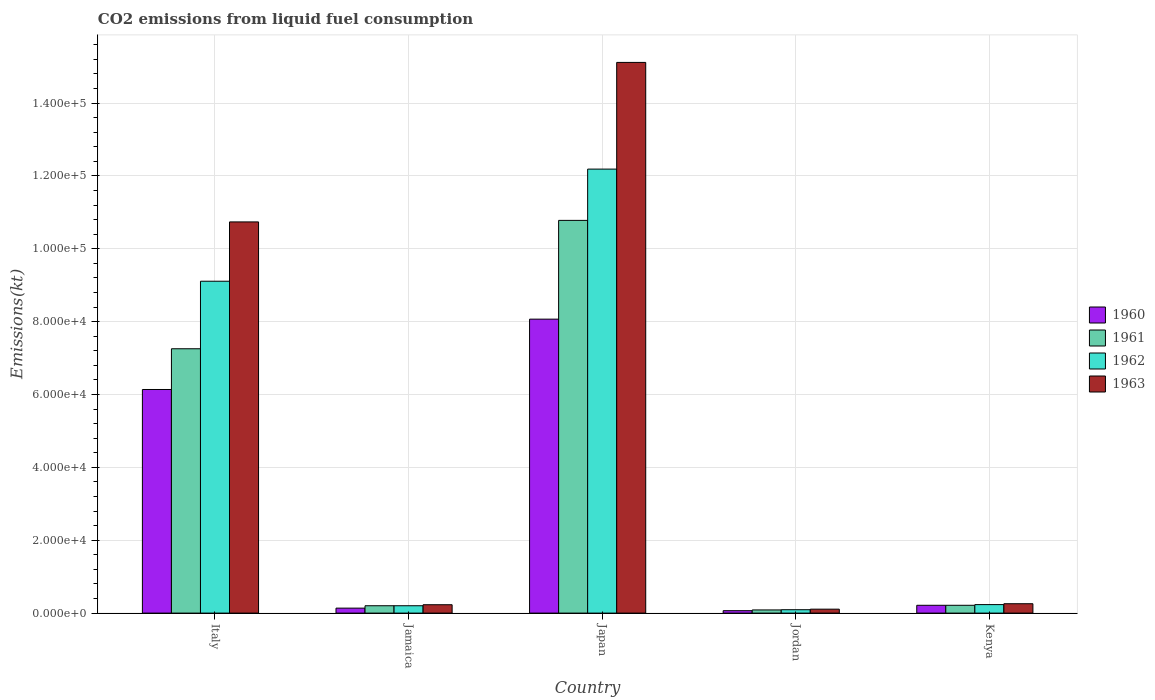How many groups of bars are there?
Make the answer very short. 5. Are the number of bars per tick equal to the number of legend labels?
Offer a very short reply. Yes. How many bars are there on the 4th tick from the right?
Offer a very short reply. 4. In how many cases, is the number of bars for a given country not equal to the number of legend labels?
Give a very brief answer. 0. What is the amount of CO2 emitted in 1963 in Jordan?
Your response must be concise. 1078.1. Across all countries, what is the maximum amount of CO2 emitted in 1960?
Your answer should be very brief. 8.07e+04. Across all countries, what is the minimum amount of CO2 emitted in 1960?
Give a very brief answer. 663.73. In which country was the amount of CO2 emitted in 1962 minimum?
Your answer should be compact. Jordan. What is the total amount of CO2 emitted in 1962 in the graph?
Keep it short and to the point. 2.18e+05. What is the difference between the amount of CO2 emitted in 1961 in Italy and that in Jamaica?
Provide a short and direct response. 7.05e+04. What is the difference between the amount of CO2 emitted in 1962 in Kenya and the amount of CO2 emitted in 1961 in Japan?
Make the answer very short. -1.05e+05. What is the average amount of CO2 emitted in 1961 per country?
Your answer should be very brief. 3.71e+04. What is the difference between the amount of CO2 emitted of/in 1963 and amount of CO2 emitted of/in 1961 in Kenya?
Provide a short and direct response. 429.04. In how many countries, is the amount of CO2 emitted in 1962 greater than 116000 kt?
Your response must be concise. 1. What is the ratio of the amount of CO2 emitted in 1961 in Japan to that in Kenya?
Your response must be concise. 50.33. What is the difference between the highest and the second highest amount of CO2 emitted in 1963?
Provide a succinct answer. 1.49e+05. What is the difference between the highest and the lowest amount of CO2 emitted in 1962?
Offer a terse response. 1.21e+05. In how many countries, is the amount of CO2 emitted in 1961 greater than the average amount of CO2 emitted in 1961 taken over all countries?
Your response must be concise. 2. Is the sum of the amount of CO2 emitted in 1962 in Jordan and Kenya greater than the maximum amount of CO2 emitted in 1963 across all countries?
Give a very brief answer. No. Is it the case that in every country, the sum of the amount of CO2 emitted in 1962 and amount of CO2 emitted in 1961 is greater than the sum of amount of CO2 emitted in 1963 and amount of CO2 emitted in 1960?
Make the answer very short. No. How many bars are there?
Keep it short and to the point. 20. Are all the bars in the graph horizontal?
Your answer should be very brief. No. How many countries are there in the graph?
Provide a short and direct response. 5. What is the difference between two consecutive major ticks on the Y-axis?
Provide a succinct answer. 2.00e+04. Does the graph contain grids?
Provide a short and direct response. Yes. How many legend labels are there?
Provide a succinct answer. 4. How are the legend labels stacked?
Provide a succinct answer. Vertical. What is the title of the graph?
Provide a succinct answer. CO2 emissions from liquid fuel consumption. What is the label or title of the X-axis?
Provide a short and direct response. Country. What is the label or title of the Y-axis?
Your response must be concise. Emissions(kt). What is the Emissions(kt) of 1960 in Italy?
Ensure brevity in your answer.  6.14e+04. What is the Emissions(kt) of 1961 in Italy?
Provide a short and direct response. 7.26e+04. What is the Emissions(kt) of 1962 in Italy?
Make the answer very short. 9.11e+04. What is the Emissions(kt) in 1963 in Italy?
Your answer should be very brief. 1.07e+05. What is the Emissions(kt) in 1960 in Jamaica?
Your answer should be compact. 1364.12. What is the Emissions(kt) in 1961 in Jamaica?
Your answer should be very brief. 2020.52. What is the Emissions(kt) in 1962 in Jamaica?
Your answer should be compact. 2016.85. What is the Emissions(kt) of 1963 in Jamaica?
Your response must be concise. 2295.54. What is the Emissions(kt) of 1960 in Japan?
Keep it short and to the point. 8.07e+04. What is the Emissions(kt) in 1961 in Japan?
Provide a succinct answer. 1.08e+05. What is the Emissions(kt) of 1962 in Japan?
Your answer should be compact. 1.22e+05. What is the Emissions(kt) in 1963 in Japan?
Offer a terse response. 1.51e+05. What is the Emissions(kt) in 1960 in Jordan?
Provide a short and direct response. 663.73. What is the Emissions(kt) of 1961 in Jordan?
Offer a terse response. 869.08. What is the Emissions(kt) of 1962 in Jordan?
Your answer should be very brief. 931.42. What is the Emissions(kt) in 1963 in Jordan?
Your answer should be compact. 1078.1. What is the Emissions(kt) of 1960 in Kenya?
Your answer should be very brief. 2141.53. What is the Emissions(kt) in 1961 in Kenya?
Your response must be concise. 2141.53. What is the Emissions(kt) in 1962 in Kenya?
Your answer should be very brief. 2332.21. What is the Emissions(kt) in 1963 in Kenya?
Offer a terse response. 2570.57. Across all countries, what is the maximum Emissions(kt) in 1960?
Offer a terse response. 8.07e+04. Across all countries, what is the maximum Emissions(kt) in 1961?
Keep it short and to the point. 1.08e+05. Across all countries, what is the maximum Emissions(kt) in 1962?
Give a very brief answer. 1.22e+05. Across all countries, what is the maximum Emissions(kt) of 1963?
Keep it short and to the point. 1.51e+05. Across all countries, what is the minimum Emissions(kt) in 1960?
Provide a short and direct response. 663.73. Across all countries, what is the minimum Emissions(kt) in 1961?
Give a very brief answer. 869.08. Across all countries, what is the minimum Emissions(kt) of 1962?
Your response must be concise. 931.42. Across all countries, what is the minimum Emissions(kt) in 1963?
Your answer should be compact. 1078.1. What is the total Emissions(kt) in 1960 in the graph?
Make the answer very short. 1.46e+05. What is the total Emissions(kt) of 1961 in the graph?
Offer a terse response. 1.85e+05. What is the total Emissions(kt) in 1962 in the graph?
Your answer should be compact. 2.18e+05. What is the total Emissions(kt) of 1963 in the graph?
Provide a short and direct response. 2.64e+05. What is the difference between the Emissions(kt) in 1960 in Italy and that in Jamaica?
Make the answer very short. 6.00e+04. What is the difference between the Emissions(kt) in 1961 in Italy and that in Jamaica?
Your answer should be compact. 7.05e+04. What is the difference between the Emissions(kt) of 1962 in Italy and that in Jamaica?
Your answer should be very brief. 8.91e+04. What is the difference between the Emissions(kt) of 1963 in Italy and that in Jamaica?
Offer a very short reply. 1.05e+05. What is the difference between the Emissions(kt) in 1960 in Italy and that in Japan?
Provide a succinct answer. -1.93e+04. What is the difference between the Emissions(kt) in 1961 in Italy and that in Japan?
Make the answer very short. -3.52e+04. What is the difference between the Emissions(kt) in 1962 in Italy and that in Japan?
Provide a succinct answer. -3.08e+04. What is the difference between the Emissions(kt) in 1963 in Italy and that in Japan?
Make the answer very short. -4.38e+04. What is the difference between the Emissions(kt) of 1960 in Italy and that in Jordan?
Make the answer very short. 6.07e+04. What is the difference between the Emissions(kt) of 1961 in Italy and that in Jordan?
Give a very brief answer. 7.17e+04. What is the difference between the Emissions(kt) of 1962 in Italy and that in Jordan?
Your answer should be very brief. 9.02e+04. What is the difference between the Emissions(kt) in 1963 in Italy and that in Jordan?
Offer a very short reply. 1.06e+05. What is the difference between the Emissions(kt) in 1960 in Italy and that in Kenya?
Your answer should be very brief. 5.92e+04. What is the difference between the Emissions(kt) in 1961 in Italy and that in Kenya?
Provide a succinct answer. 7.04e+04. What is the difference between the Emissions(kt) of 1962 in Italy and that in Kenya?
Ensure brevity in your answer.  8.88e+04. What is the difference between the Emissions(kt) in 1963 in Italy and that in Kenya?
Your response must be concise. 1.05e+05. What is the difference between the Emissions(kt) in 1960 in Jamaica and that in Japan?
Your response must be concise. -7.93e+04. What is the difference between the Emissions(kt) of 1961 in Jamaica and that in Japan?
Keep it short and to the point. -1.06e+05. What is the difference between the Emissions(kt) in 1962 in Jamaica and that in Japan?
Make the answer very short. -1.20e+05. What is the difference between the Emissions(kt) in 1963 in Jamaica and that in Japan?
Provide a short and direct response. -1.49e+05. What is the difference between the Emissions(kt) of 1960 in Jamaica and that in Jordan?
Your answer should be compact. 700.4. What is the difference between the Emissions(kt) in 1961 in Jamaica and that in Jordan?
Provide a short and direct response. 1151.44. What is the difference between the Emissions(kt) in 1962 in Jamaica and that in Jordan?
Your answer should be compact. 1085.43. What is the difference between the Emissions(kt) of 1963 in Jamaica and that in Jordan?
Provide a succinct answer. 1217.44. What is the difference between the Emissions(kt) in 1960 in Jamaica and that in Kenya?
Make the answer very short. -777.4. What is the difference between the Emissions(kt) of 1961 in Jamaica and that in Kenya?
Offer a terse response. -121.01. What is the difference between the Emissions(kt) in 1962 in Jamaica and that in Kenya?
Provide a succinct answer. -315.36. What is the difference between the Emissions(kt) in 1963 in Jamaica and that in Kenya?
Offer a terse response. -275.02. What is the difference between the Emissions(kt) of 1960 in Japan and that in Jordan?
Ensure brevity in your answer.  8.00e+04. What is the difference between the Emissions(kt) of 1961 in Japan and that in Jordan?
Keep it short and to the point. 1.07e+05. What is the difference between the Emissions(kt) of 1962 in Japan and that in Jordan?
Offer a very short reply. 1.21e+05. What is the difference between the Emissions(kt) in 1963 in Japan and that in Jordan?
Make the answer very short. 1.50e+05. What is the difference between the Emissions(kt) in 1960 in Japan and that in Kenya?
Provide a succinct answer. 7.85e+04. What is the difference between the Emissions(kt) of 1961 in Japan and that in Kenya?
Keep it short and to the point. 1.06e+05. What is the difference between the Emissions(kt) of 1962 in Japan and that in Kenya?
Offer a very short reply. 1.20e+05. What is the difference between the Emissions(kt) in 1963 in Japan and that in Kenya?
Offer a terse response. 1.49e+05. What is the difference between the Emissions(kt) of 1960 in Jordan and that in Kenya?
Make the answer very short. -1477.8. What is the difference between the Emissions(kt) of 1961 in Jordan and that in Kenya?
Make the answer very short. -1272.45. What is the difference between the Emissions(kt) in 1962 in Jordan and that in Kenya?
Your response must be concise. -1400.79. What is the difference between the Emissions(kt) of 1963 in Jordan and that in Kenya?
Keep it short and to the point. -1492.47. What is the difference between the Emissions(kt) in 1960 in Italy and the Emissions(kt) in 1961 in Jamaica?
Keep it short and to the point. 5.94e+04. What is the difference between the Emissions(kt) in 1960 in Italy and the Emissions(kt) in 1962 in Jamaica?
Offer a terse response. 5.94e+04. What is the difference between the Emissions(kt) in 1960 in Italy and the Emissions(kt) in 1963 in Jamaica?
Offer a terse response. 5.91e+04. What is the difference between the Emissions(kt) of 1961 in Italy and the Emissions(kt) of 1962 in Jamaica?
Offer a very short reply. 7.05e+04. What is the difference between the Emissions(kt) in 1961 in Italy and the Emissions(kt) in 1963 in Jamaica?
Offer a terse response. 7.03e+04. What is the difference between the Emissions(kt) of 1962 in Italy and the Emissions(kt) of 1963 in Jamaica?
Make the answer very short. 8.88e+04. What is the difference between the Emissions(kt) of 1960 in Italy and the Emissions(kt) of 1961 in Japan?
Offer a terse response. -4.64e+04. What is the difference between the Emissions(kt) in 1960 in Italy and the Emissions(kt) in 1962 in Japan?
Offer a very short reply. -6.05e+04. What is the difference between the Emissions(kt) of 1960 in Italy and the Emissions(kt) of 1963 in Japan?
Make the answer very short. -8.98e+04. What is the difference between the Emissions(kt) of 1961 in Italy and the Emissions(kt) of 1962 in Japan?
Offer a terse response. -4.93e+04. What is the difference between the Emissions(kt) of 1961 in Italy and the Emissions(kt) of 1963 in Japan?
Provide a short and direct response. -7.86e+04. What is the difference between the Emissions(kt) of 1962 in Italy and the Emissions(kt) of 1963 in Japan?
Ensure brevity in your answer.  -6.01e+04. What is the difference between the Emissions(kt) in 1960 in Italy and the Emissions(kt) in 1961 in Jordan?
Your response must be concise. 6.05e+04. What is the difference between the Emissions(kt) of 1960 in Italy and the Emissions(kt) of 1962 in Jordan?
Ensure brevity in your answer.  6.04e+04. What is the difference between the Emissions(kt) in 1960 in Italy and the Emissions(kt) in 1963 in Jordan?
Keep it short and to the point. 6.03e+04. What is the difference between the Emissions(kt) of 1961 in Italy and the Emissions(kt) of 1962 in Jordan?
Offer a terse response. 7.16e+04. What is the difference between the Emissions(kt) of 1961 in Italy and the Emissions(kt) of 1963 in Jordan?
Keep it short and to the point. 7.15e+04. What is the difference between the Emissions(kt) in 1962 in Italy and the Emissions(kt) in 1963 in Jordan?
Offer a terse response. 9.00e+04. What is the difference between the Emissions(kt) in 1960 in Italy and the Emissions(kt) in 1961 in Kenya?
Provide a succinct answer. 5.92e+04. What is the difference between the Emissions(kt) of 1960 in Italy and the Emissions(kt) of 1962 in Kenya?
Keep it short and to the point. 5.90e+04. What is the difference between the Emissions(kt) in 1960 in Italy and the Emissions(kt) in 1963 in Kenya?
Ensure brevity in your answer.  5.88e+04. What is the difference between the Emissions(kt) of 1961 in Italy and the Emissions(kt) of 1962 in Kenya?
Provide a succinct answer. 7.02e+04. What is the difference between the Emissions(kt) of 1961 in Italy and the Emissions(kt) of 1963 in Kenya?
Give a very brief answer. 7.00e+04. What is the difference between the Emissions(kt) of 1962 in Italy and the Emissions(kt) of 1963 in Kenya?
Give a very brief answer. 8.85e+04. What is the difference between the Emissions(kt) of 1960 in Jamaica and the Emissions(kt) of 1961 in Japan?
Your response must be concise. -1.06e+05. What is the difference between the Emissions(kt) in 1960 in Jamaica and the Emissions(kt) in 1962 in Japan?
Your response must be concise. -1.20e+05. What is the difference between the Emissions(kt) in 1960 in Jamaica and the Emissions(kt) in 1963 in Japan?
Make the answer very short. -1.50e+05. What is the difference between the Emissions(kt) of 1961 in Jamaica and the Emissions(kt) of 1962 in Japan?
Offer a terse response. -1.20e+05. What is the difference between the Emissions(kt) in 1961 in Jamaica and the Emissions(kt) in 1963 in Japan?
Offer a terse response. -1.49e+05. What is the difference between the Emissions(kt) in 1962 in Jamaica and the Emissions(kt) in 1963 in Japan?
Ensure brevity in your answer.  -1.49e+05. What is the difference between the Emissions(kt) in 1960 in Jamaica and the Emissions(kt) in 1961 in Jordan?
Provide a succinct answer. 495.05. What is the difference between the Emissions(kt) in 1960 in Jamaica and the Emissions(kt) in 1962 in Jordan?
Provide a succinct answer. 432.71. What is the difference between the Emissions(kt) of 1960 in Jamaica and the Emissions(kt) of 1963 in Jordan?
Your answer should be compact. 286.03. What is the difference between the Emissions(kt) in 1961 in Jamaica and the Emissions(kt) in 1962 in Jordan?
Offer a terse response. 1089.1. What is the difference between the Emissions(kt) of 1961 in Jamaica and the Emissions(kt) of 1963 in Jordan?
Your answer should be compact. 942.42. What is the difference between the Emissions(kt) of 1962 in Jamaica and the Emissions(kt) of 1963 in Jordan?
Offer a very short reply. 938.75. What is the difference between the Emissions(kt) of 1960 in Jamaica and the Emissions(kt) of 1961 in Kenya?
Give a very brief answer. -777.4. What is the difference between the Emissions(kt) in 1960 in Jamaica and the Emissions(kt) in 1962 in Kenya?
Your answer should be compact. -968.09. What is the difference between the Emissions(kt) of 1960 in Jamaica and the Emissions(kt) of 1963 in Kenya?
Your answer should be very brief. -1206.44. What is the difference between the Emissions(kt) of 1961 in Jamaica and the Emissions(kt) of 1962 in Kenya?
Provide a short and direct response. -311.69. What is the difference between the Emissions(kt) of 1961 in Jamaica and the Emissions(kt) of 1963 in Kenya?
Ensure brevity in your answer.  -550.05. What is the difference between the Emissions(kt) in 1962 in Jamaica and the Emissions(kt) in 1963 in Kenya?
Keep it short and to the point. -553.72. What is the difference between the Emissions(kt) of 1960 in Japan and the Emissions(kt) of 1961 in Jordan?
Give a very brief answer. 7.98e+04. What is the difference between the Emissions(kt) of 1960 in Japan and the Emissions(kt) of 1962 in Jordan?
Your response must be concise. 7.97e+04. What is the difference between the Emissions(kt) in 1960 in Japan and the Emissions(kt) in 1963 in Jordan?
Make the answer very short. 7.96e+04. What is the difference between the Emissions(kt) in 1961 in Japan and the Emissions(kt) in 1962 in Jordan?
Keep it short and to the point. 1.07e+05. What is the difference between the Emissions(kt) in 1961 in Japan and the Emissions(kt) in 1963 in Jordan?
Your answer should be compact. 1.07e+05. What is the difference between the Emissions(kt) in 1962 in Japan and the Emissions(kt) in 1963 in Jordan?
Give a very brief answer. 1.21e+05. What is the difference between the Emissions(kt) of 1960 in Japan and the Emissions(kt) of 1961 in Kenya?
Make the answer very short. 7.85e+04. What is the difference between the Emissions(kt) in 1960 in Japan and the Emissions(kt) in 1962 in Kenya?
Keep it short and to the point. 7.83e+04. What is the difference between the Emissions(kt) of 1960 in Japan and the Emissions(kt) of 1963 in Kenya?
Provide a succinct answer. 7.81e+04. What is the difference between the Emissions(kt) in 1961 in Japan and the Emissions(kt) in 1962 in Kenya?
Provide a succinct answer. 1.05e+05. What is the difference between the Emissions(kt) of 1961 in Japan and the Emissions(kt) of 1963 in Kenya?
Offer a terse response. 1.05e+05. What is the difference between the Emissions(kt) of 1962 in Japan and the Emissions(kt) of 1963 in Kenya?
Provide a succinct answer. 1.19e+05. What is the difference between the Emissions(kt) in 1960 in Jordan and the Emissions(kt) in 1961 in Kenya?
Provide a short and direct response. -1477.8. What is the difference between the Emissions(kt) in 1960 in Jordan and the Emissions(kt) in 1962 in Kenya?
Keep it short and to the point. -1668.48. What is the difference between the Emissions(kt) of 1960 in Jordan and the Emissions(kt) of 1963 in Kenya?
Provide a short and direct response. -1906.84. What is the difference between the Emissions(kt) of 1961 in Jordan and the Emissions(kt) of 1962 in Kenya?
Keep it short and to the point. -1463.13. What is the difference between the Emissions(kt) of 1961 in Jordan and the Emissions(kt) of 1963 in Kenya?
Provide a short and direct response. -1701.49. What is the difference between the Emissions(kt) in 1962 in Jordan and the Emissions(kt) in 1963 in Kenya?
Your response must be concise. -1639.15. What is the average Emissions(kt) in 1960 per country?
Make the answer very short. 2.92e+04. What is the average Emissions(kt) of 1961 per country?
Keep it short and to the point. 3.71e+04. What is the average Emissions(kt) in 1962 per country?
Your response must be concise. 4.36e+04. What is the average Emissions(kt) of 1963 per country?
Your answer should be very brief. 5.29e+04. What is the difference between the Emissions(kt) in 1960 and Emissions(kt) in 1961 in Italy?
Ensure brevity in your answer.  -1.12e+04. What is the difference between the Emissions(kt) in 1960 and Emissions(kt) in 1962 in Italy?
Offer a very short reply. -2.97e+04. What is the difference between the Emissions(kt) of 1960 and Emissions(kt) of 1963 in Italy?
Give a very brief answer. -4.60e+04. What is the difference between the Emissions(kt) of 1961 and Emissions(kt) of 1962 in Italy?
Your response must be concise. -1.85e+04. What is the difference between the Emissions(kt) of 1961 and Emissions(kt) of 1963 in Italy?
Make the answer very short. -3.48e+04. What is the difference between the Emissions(kt) in 1962 and Emissions(kt) in 1963 in Italy?
Give a very brief answer. -1.63e+04. What is the difference between the Emissions(kt) of 1960 and Emissions(kt) of 1961 in Jamaica?
Offer a terse response. -656.39. What is the difference between the Emissions(kt) of 1960 and Emissions(kt) of 1962 in Jamaica?
Offer a terse response. -652.73. What is the difference between the Emissions(kt) in 1960 and Emissions(kt) in 1963 in Jamaica?
Your answer should be very brief. -931.42. What is the difference between the Emissions(kt) of 1961 and Emissions(kt) of 1962 in Jamaica?
Ensure brevity in your answer.  3.67. What is the difference between the Emissions(kt) in 1961 and Emissions(kt) in 1963 in Jamaica?
Give a very brief answer. -275.02. What is the difference between the Emissions(kt) of 1962 and Emissions(kt) of 1963 in Jamaica?
Your answer should be very brief. -278.69. What is the difference between the Emissions(kt) in 1960 and Emissions(kt) in 1961 in Japan?
Make the answer very short. -2.71e+04. What is the difference between the Emissions(kt) of 1960 and Emissions(kt) of 1962 in Japan?
Your response must be concise. -4.12e+04. What is the difference between the Emissions(kt) of 1960 and Emissions(kt) of 1963 in Japan?
Provide a succinct answer. -7.05e+04. What is the difference between the Emissions(kt) of 1961 and Emissions(kt) of 1962 in Japan?
Provide a succinct answer. -1.41e+04. What is the difference between the Emissions(kt) in 1961 and Emissions(kt) in 1963 in Japan?
Offer a terse response. -4.34e+04. What is the difference between the Emissions(kt) in 1962 and Emissions(kt) in 1963 in Japan?
Give a very brief answer. -2.93e+04. What is the difference between the Emissions(kt) in 1960 and Emissions(kt) in 1961 in Jordan?
Make the answer very short. -205.35. What is the difference between the Emissions(kt) in 1960 and Emissions(kt) in 1962 in Jordan?
Provide a succinct answer. -267.69. What is the difference between the Emissions(kt) of 1960 and Emissions(kt) of 1963 in Jordan?
Provide a short and direct response. -414.37. What is the difference between the Emissions(kt) in 1961 and Emissions(kt) in 1962 in Jordan?
Your answer should be very brief. -62.34. What is the difference between the Emissions(kt) in 1961 and Emissions(kt) in 1963 in Jordan?
Your response must be concise. -209.02. What is the difference between the Emissions(kt) in 1962 and Emissions(kt) in 1963 in Jordan?
Your answer should be compact. -146.68. What is the difference between the Emissions(kt) in 1960 and Emissions(kt) in 1962 in Kenya?
Your response must be concise. -190.68. What is the difference between the Emissions(kt) of 1960 and Emissions(kt) of 1963 in Kenya?
Offer a terse response. -429.04. What is the difference between the Emissions(kt) of 1961 and Emissions(kt) of 1962 in Kenya?
Your answer should be very brief. -190.68. What is the difference between the Emissions(kt) of 1961 and Emissions(kt) of 1963 in Kenya?
Give a very brief answer. -429.04. What is the difference between the Emissions(kt) of 1962 and Emissions(kt) of 1963 in Kenya?
Make the answer very short. -238.35. What is the ratio of the Emissions(kt) in 1960 in Italy to that in Jamaica?
Provide a short and direct response. 44.99. What is the ratio of the Emissions(kt) of 1961 in Italy to that in Jamaica?
Provide a short and direct response. 35.91. What is the ratio of the Emissions(kt) of 1962 in Italy to that in Jamaica?
Ensure brevity in your answer.  45.16. What is the ratio of the Emissions(kt) in 1963 in Italy to that in Jamaica?
Your answer should be compact. 46.77. What is the ratio of the Emissions(kt) of 1960 in Italy to that in Japan?
Provide a short and direct response. 0.76. What is the ratio of the Emissions(kt) in 1961 in Italy to that in Japan?
Provide a succinct answer. 0.67. What is the ratio of the Emissions(kt) of 1962 in Italy to that in Japan?
Provide a short and direct response. 0.75. What is the ratio of the Emissions(kt) of 1963 in Italy to that in Japan?
Your answer should be very brief. 0.71. What is the ratio of the Emissions(kt) in 1960 in Italy to that in Jordan?
Your answer should be very brief. 92.47. What is the ratio of the Emissions(kt) of 1961 in Italy to that in Jordan?
Your answer should be very brief. 83.48. What is the ratio of the Emissions(kt) of 1962 in Italy to that in Jordan?
Provide a short and direct response. 97.8. What is the ratio of the Emissions(kt) of 1963 in Italy to that in Jordan?
Keep it short and to the point. 99.59. What is the ratio of the Emissions(kt) in 1960 in Italy to that in Kenya?
Ensure brevity in your answer.  28.66. What is the ratio of the Emissions(kt) of 1961 in Italy to that in Kenya?
Your answer should be very brief. 33.88. What is the ratio of the Emissions(kt) of 1962 in Italy to that in Kenya?
Offer a very short reply. 39.06. What is the ratio of the Emissions(kt) of 1963 in Italy to that in Kenya?
Your response must be concise. 41.77. What is the ratio of the Emissions(kt) in 1960 in Jamaica to that in Japan?
Your response must be concise. 0.02. What is the ratio of the Emissions(kt) in 1961 in Jamaica to that in Japan?
Give a very brief answer. 0.02. What is the ratio of the Emissions(kt) of 1962 in Jamaica to that in Japan?
Your answer should be compact. 0.02. What is the ratio of the Emissions(kt) in 1963 in Jamaica to that in Japan?
Your response must be concise. 0.02. What is the ratio of the Emissions(kt) of 1960 in Jamaica to that in Jordan?
Your answer should be very brief. 2.06. What is the ratio of the Emissions(kt) in 1961 in Jamaica to that in Jordan?
Keep it short and to the point. 2.32. What is the ratio of the Emissions(kt) of 1962 in Jamaica to that in Jordan?
Your response must be concise. 2.17. What is the ratio of the Emissions(kt) of 1963 in Jamaica to that in Jordan?
Offer a terse response. 2.13. What is the ratio of the Emissions(kt) of 1960 in Jamaica to that in Kenya?
Offer a very short reply. 0.64. What is the ratio of the Emissions(kt) of 1961 in Jamaica to that in Kenya?
Give a very brief answer. 0.94. What is the ratio of the Emissions(kt) of 1962 in Jamaica to that in Kenya?
Provide a short and direct response. 0.86. What is the ratio of the Emissions(kt) in 1963 in Jamaica to that in Kenya?
Your answer should be compact. 0.89. What is the ratio of the Emissions(kt) of 1960 in Japan to that in Jordan?
Your answer should be compact. 121.56. What is the ratio of the Emissions(kt) in 1961 in Japan to that in Jordan?
Your answer should be compact. 124.03. What is the ratio of the Emissions(kt) of 1962 in Japan to that in Jordan?
Provide a short and direct response. 130.83. What is the ratio of the Emissions(kt) of 1963 in Japan to that in Jordan?
Provide a succinct answer. 140.2. What is the ratio of the Emissions(kt) of 1960 in Japan to that in Kenya?
Your response must be concise. 37.67. What is the ratio of the Emissions(kt) in 1961 in Japan to that in Kenya?
Provide a short and direct response. 50.33. What is the ratio of the Emissions(kt) of 1962 in Japan to that in Kenya?
Keep it short and to the point. 52.25. What is the ratio of the Emissions(kt) of 1963 in Japan to that in Kenya?
Your answer should be very brief. 58.8. What is the ratio of the Emissions(kt) of 1960 in Jordan to that in Kenya?
Your answer should be compact. 0.31. What is the ratio of the Emissions(kt) in 1961 in Jordan to that in Kenya?
Keep it short and to the point. 0.41. What is the ratio of the Emissions(kt) of 1962 in Jordan to that in Kenya?
Offer a terse response. 0.4. What is the ratio of the Emissions(kt) in 1963 in Jordan to that in Kenya?
Make the answer very short. 0.42. What is the difference between the highest and the second highest Emissions(kt) in 1960?
Ensure brevity in your answer.  1.93e+04. What is the difference between the highest and the second highest Emissions(kt) of 1961?
Offer a very short reply. 3.52e+04. What is the difference between the highest and the second highest Emissions(kt) in 1962?
Ensure brevity in your answer.  3.08e+04. What is the difference between the highest and the second highest Emissions(kt) in 1963?
Keep it short and to the point. 4.38e+04. What is the difference between the highest and the lowest Emissions(kt) in 1960?
Provide a succinct answer. 8.00e+04. What is the difference between the highest and the lowest Emissions(kt) of 1961?
Make the answer very short. 1.07e+05. What is the difference between the highest and the lowest Emissions(kt) in 1962?
Offer a very short reply. 1.21e+05. What is the difference between the highest and the lowest Emissions(kt) in 1963?
Provide a succinct answer. 1.50e+05. 